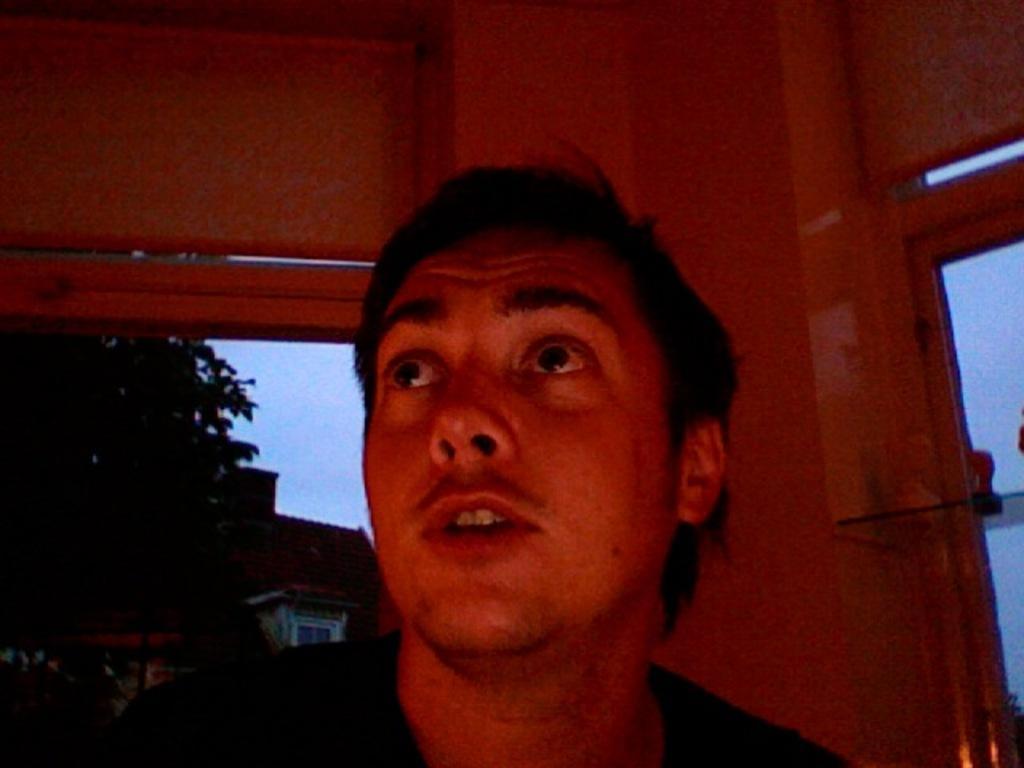Please provide a concise description of this image. In this image I can see a man is looking at the top. On the left side there are trees and buildings. 